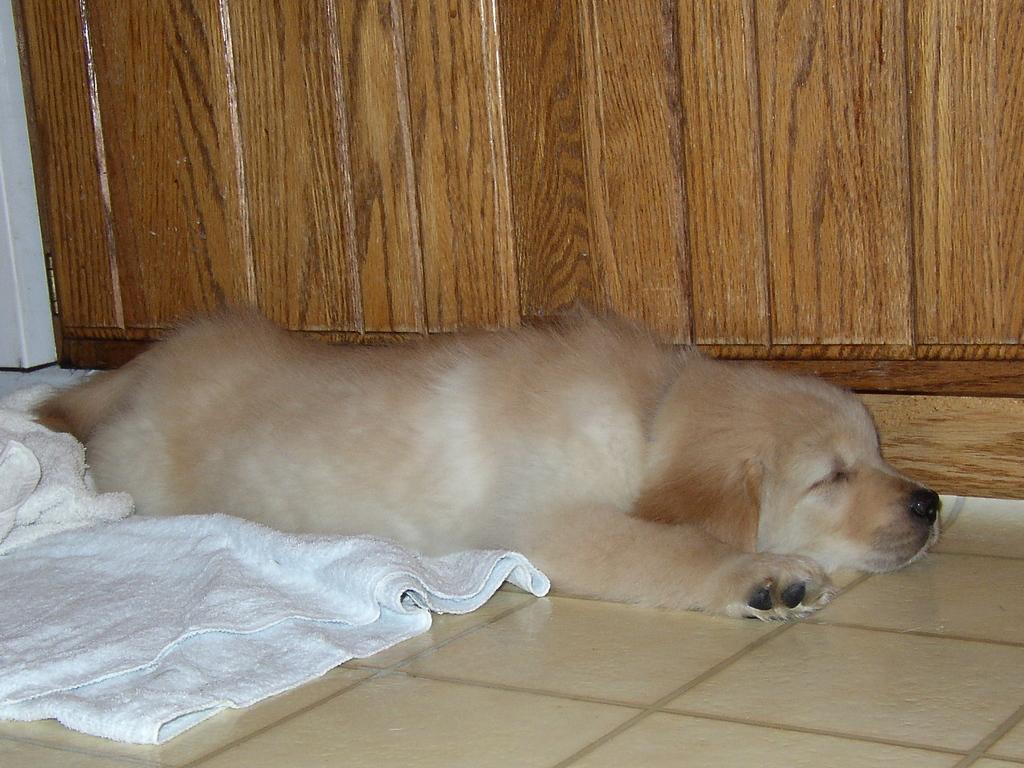In one or two sentences, can you explain what this image depicts? In this image we can see a dog lying on a cloth placed on the floor. In the background ,we can see cupboard. 